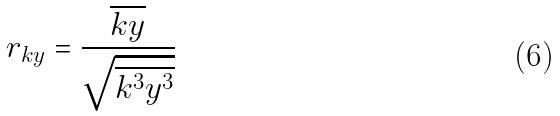<formula> <loc_0><loc_0><loc_500><loc_500>r _ { k y } = \frac { \overline { k y } } { \sqrt { \overline { k ^ { 3 } } \overline { y ^ { 3 } } } }</formula> 